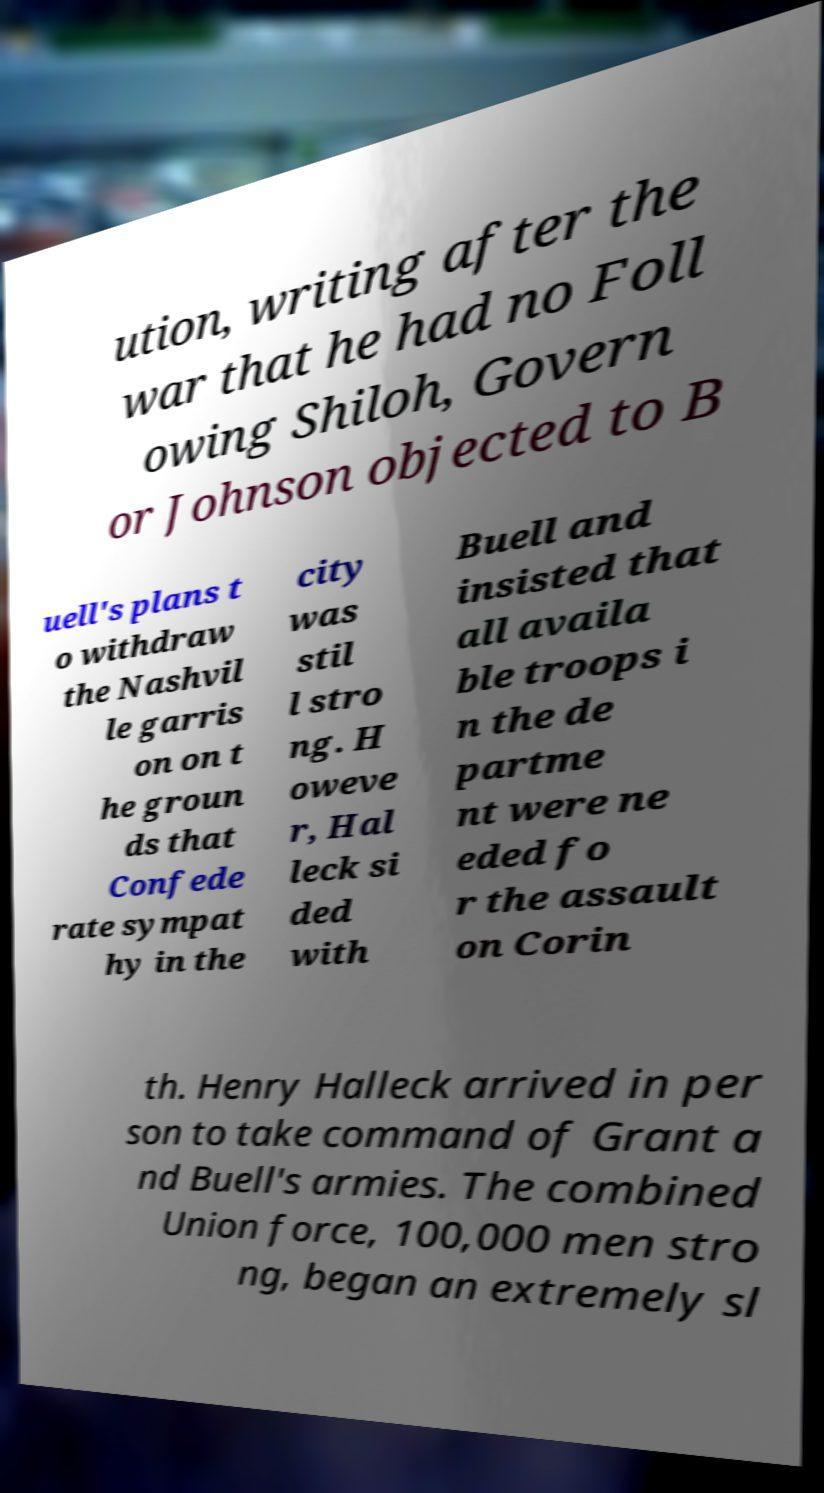There's text embedded in this image that I need extracted. Can you transcribe it verbatim? ution, writing after the war that he had no Foll owing Shiloh, Govern or Johnson objected to B uell's plans t o withdraw the Nashvil le garris on on t he groun ds that Confede rate sympat hy in the city was stil l stro ng. H oweve r, Hal leck si ded with Buell and insisted that all availa ble troops i n the de partme nt were ne eded fo r the assault on Corin th. Henry Halleck arrived in per son to take command of Grant a nd Buell's armies. The combined Union force, 100,000 men stro ng, began an extremely sl 